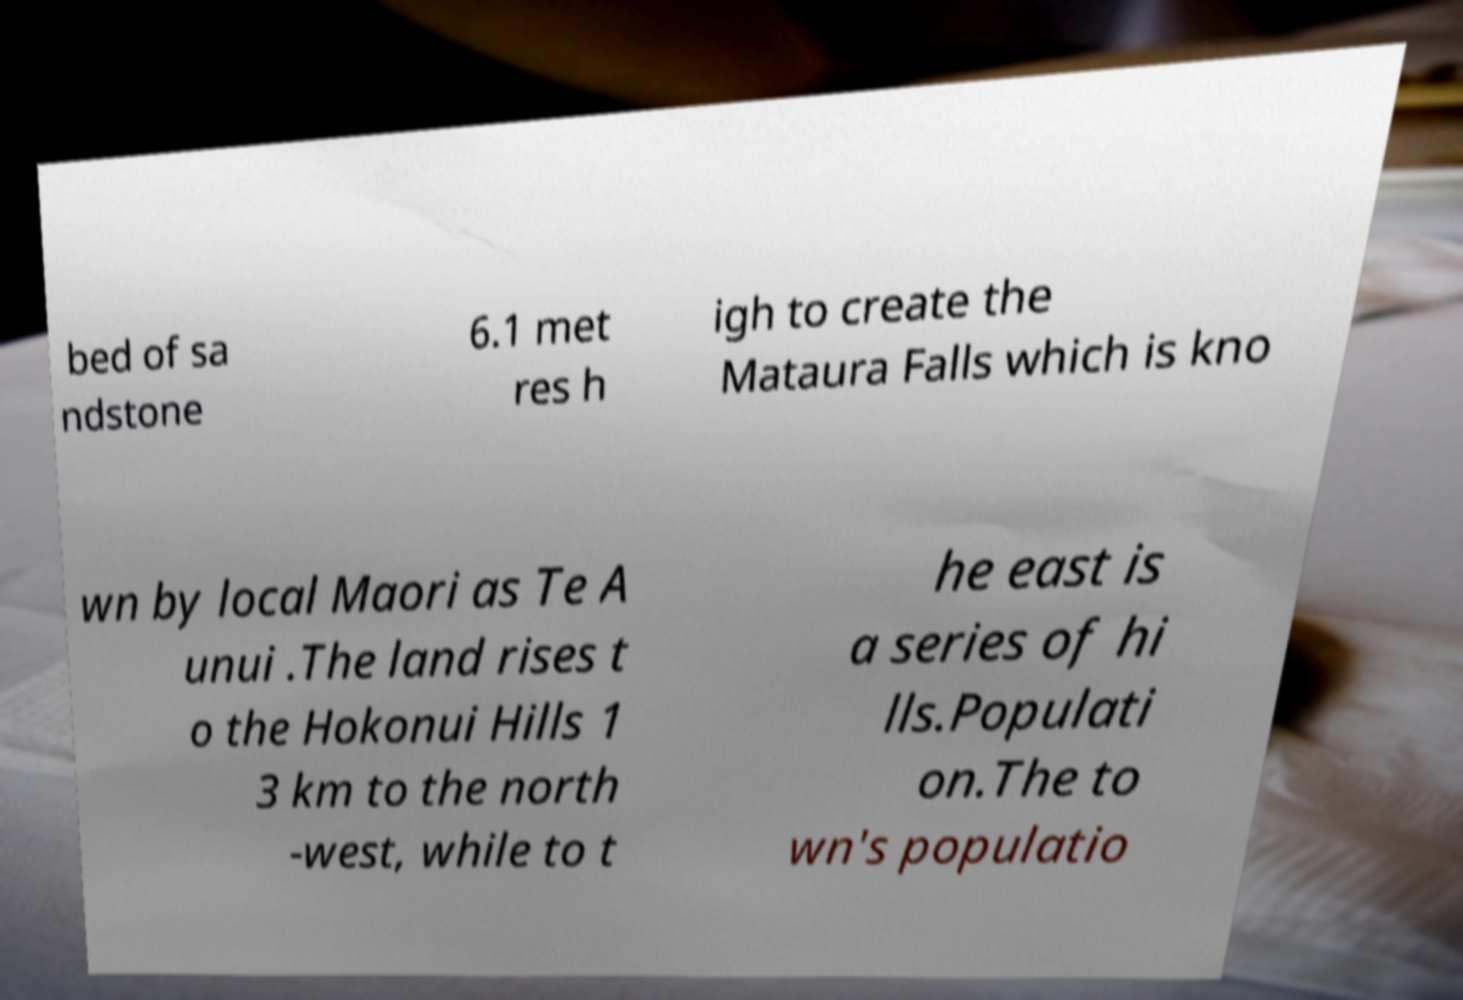Can you read and provide the text displayed in the image?This photo seems to have some interesting text. Can you extract and type it out for me? bed of sa ndstone 6.1 met res h igh to create the Mataura Falls which is kno wn by local Maori as Te A unui .The land rises t o the Hokonui Hills 1 3 km to the north -west, while to t he east is a series of hi lls.Populati on.The to wn's populatio 